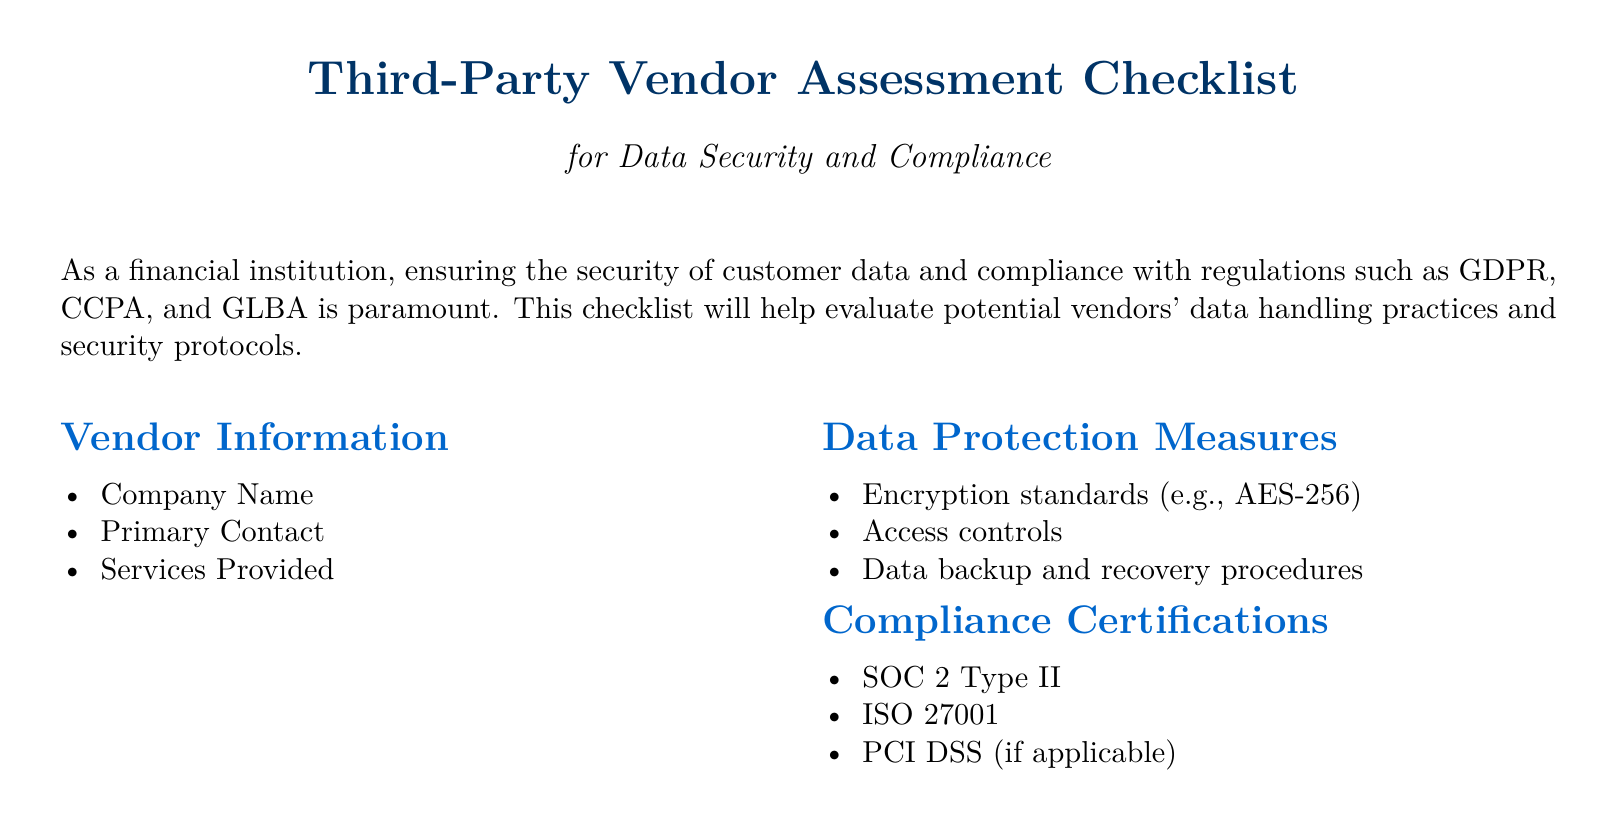What is the title of the document? The title reflects the purpose of the document and is "Third-Party Vendor Assessment Checklist."
Answer: Third-Party Vendor Assessment Checklist What is the primary focus of the checklist? The primary focus is on evaluating vendors for data security and compliance.
Answer: Data security and compliance List one of the compliance certifications mentioned. The document includes several compliance certifications; one example is SOC 2 Type II.
Answer: SOC 2 Type II What encryption standard is specified in the document? The checklist mentions a specific encryption standard for data protection.
Answer: AES-256 What is one incident response measure noted in the checklist? The document lists various incident response measures; one mentioned is the breach notification process.
Answer: Breach notification process How many columns are used in the document layout? The layout of the document is structured into two columns.
Answer: Two According to the document, what is one regulatory compliance requirement? The document specifies several regulatory compliance requirements; one is GDPR compliance.
Answer: GDPR compliance What is the recommended action for further information as indicated in the document? The document advises consulting with a compliance officer or legal counsel for more details.
Answer: Consult with your compliance officer or legal counsel What is the purpose of this checklist as stated in the document? The checklist serves to help financial institutions assess third-party vendors in accordance to specific criteria.
Answer: Assess third-party vendors 